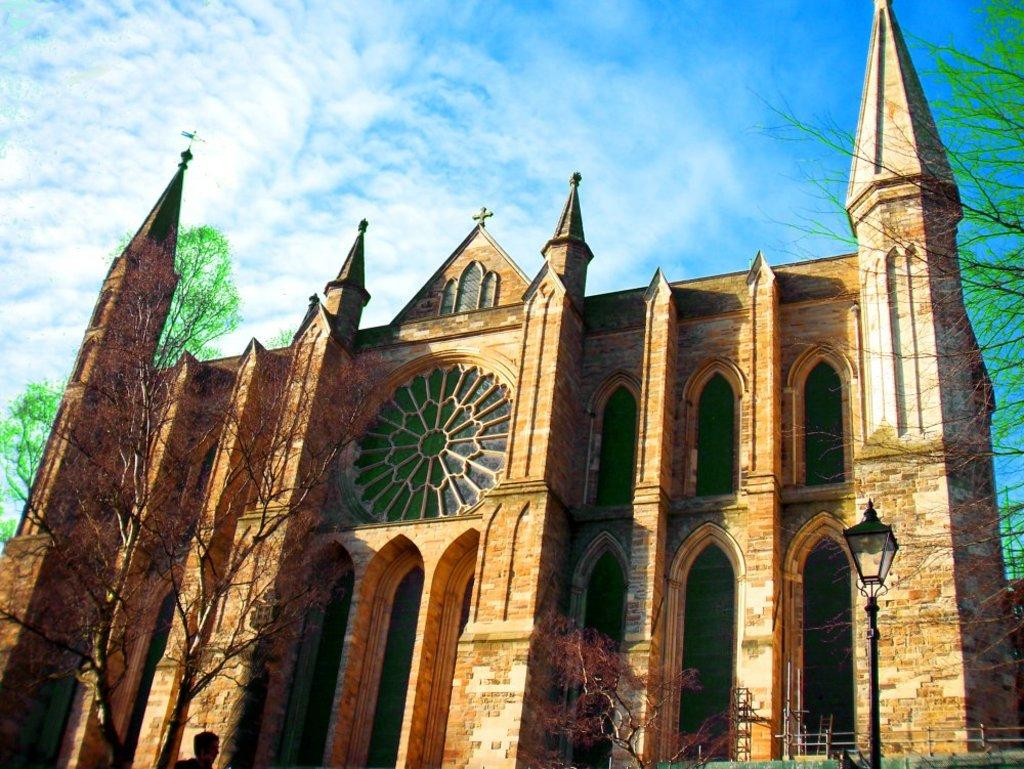What type of vegetation can be seen in the image? There are trees in the image. What colors are the trees in the image? The trees are green and brown in color. What type of structure is visible in the image? There is a building in the image. What colors are the building in the image? The building is brown, black, and cream in color. What is visible in the background of the image? The sky is visible in the background of the image. Can you tell me how many spiders are crawling on the building in the image? There are no spiders visible in the image; it only features trees, a building, and the sky. What actor is performing in the event taking place in the image? There is no event or actor present in the image; it is a static scene with trees, a building, and the sky. 